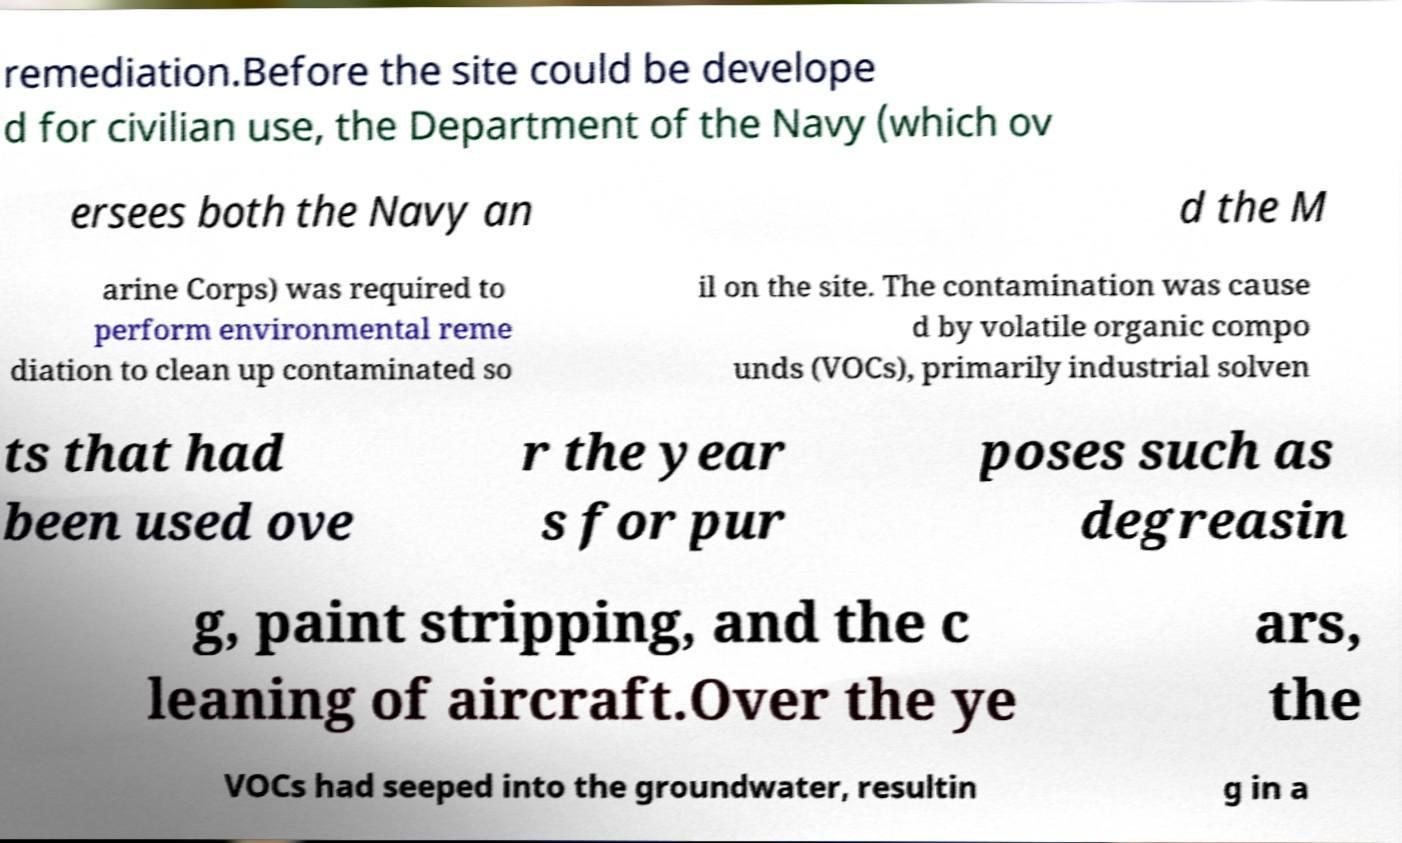Could you extract and type out the text from this image? remediation.Before the site could be develope d for civilian use, the Department of the Navy (which ov ersees both the Navy an d the M arine Corps) was required to perform environmental reme diation to clean up contaminated so il on the site. The contamination was cause d by volatile organic compo unds (VOCs), primarily industrial solven ts that had been used ove r the year s for pur poses such as degreasin g, paint stripping, and the c leaning of aircraft.Over the ye ars, the VOCs had seeped into the groundwater, resultin g in a 